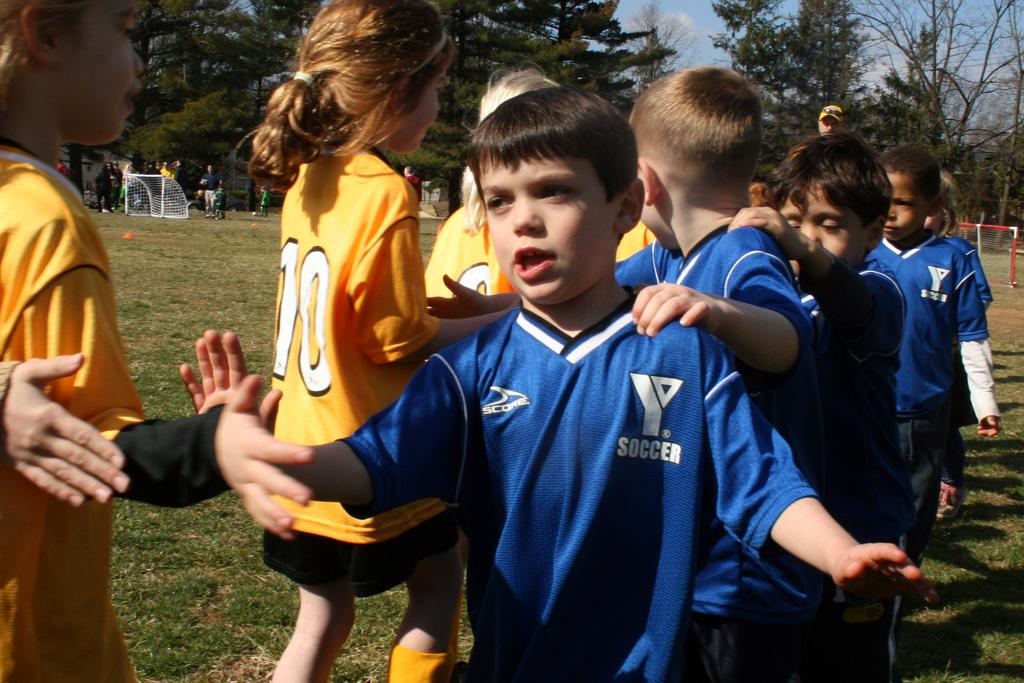<image>
Summarize the visual content of the image. Boy wearing a blue shirt that says Soccer on it. 